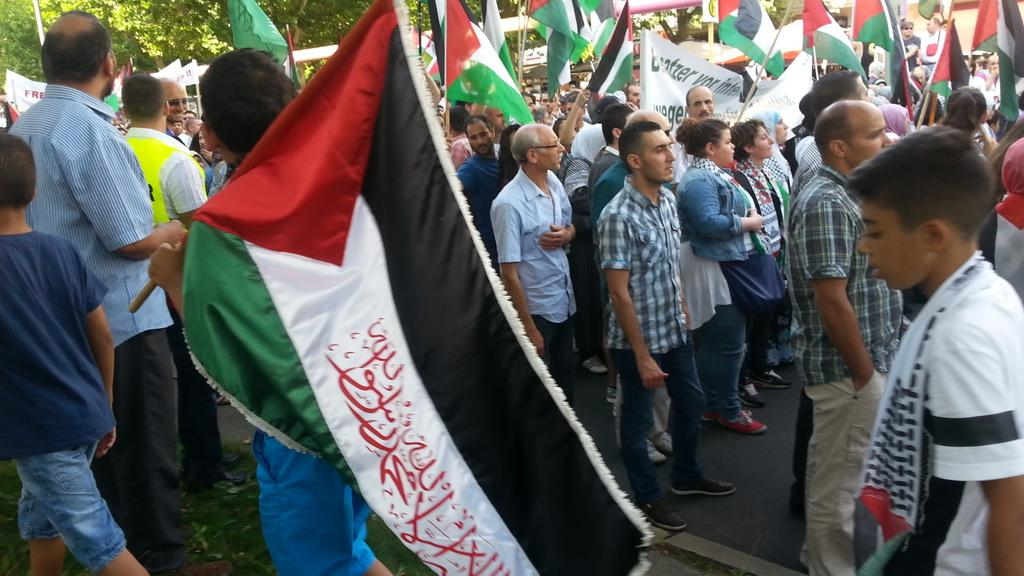How many people are in the image? There is a group of people in the image. What are some of the people holding? Some people are holding flags. What colors are on the flag? The flag has black, white, green, and red colors. What can be seen in the background of the image? There are trees in the background of the image. What is the color of the trees? The trees are green in color. Are there any giants participating in the battle depicted in the image? There is no battle or giants present in the image; it features a group of people holding flags with a background of green trees. 